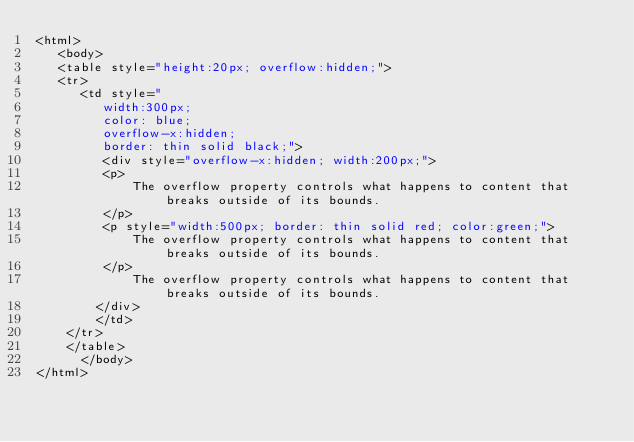Convert code to text. <code><loc_0><loc_0><loc_500><loc_500><_HTML_><html>
   <body>
   <table style="height:20px; overflow:hidden;">
   <tr>
      <td style="
         width:300px;
		 color: blue;
		 overflow-x:hidden;
		 border: thin solid black;">
		 <div style="overflow-x:hidden; width:200px;">
         <p>
             The overflow property controls what happens to content that breaks outside of its bounds.
         </p>
		 <p style="width:500px; border: thin solid red; color:green;">
             The overflow property controls what happens to content that breaks outside of its bounds.
         </p>
             The overflow property controls what happens to content that breaks outside of its bounds.
		</div>
		</td>
	</tr>
	</table>
	  </body>
</html>
</code> 